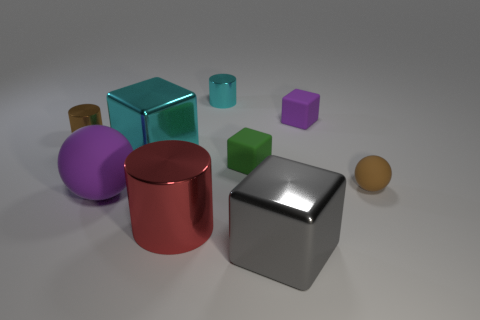Is there a pattern to the arrangement of the objects? There doesn't seem to be a deliberate pattern to the arrangement of the objects. They are placed in a somewhat scattered formation, which does not follow any recognizable sequence or symmetry. 